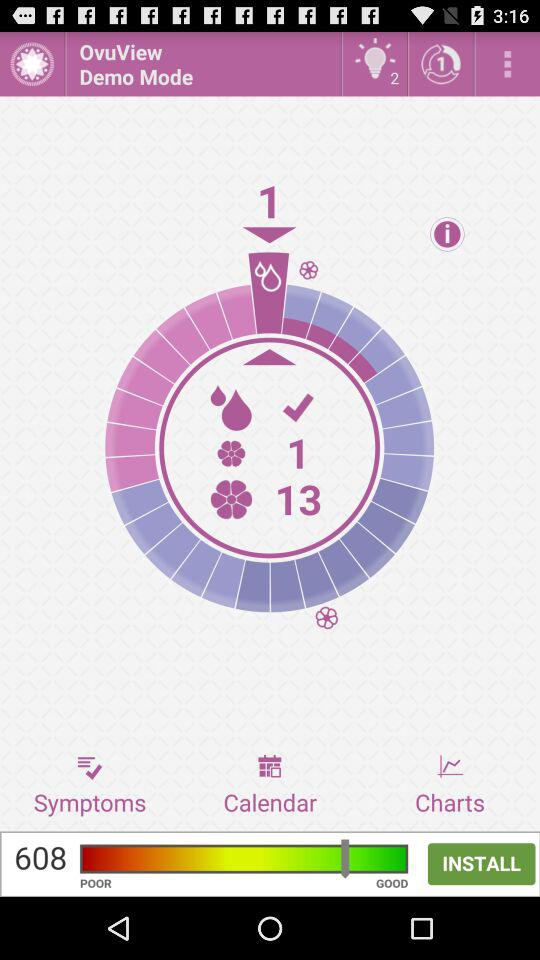What is the name of the application? The name of the application is "OvuView". 